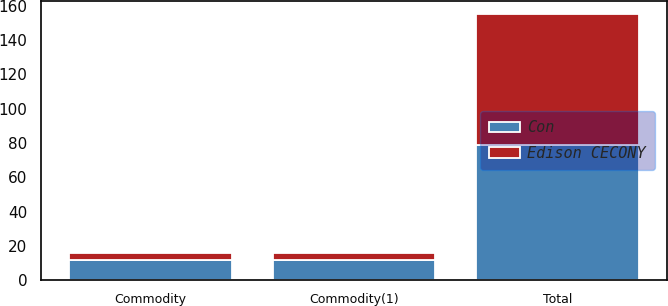<chart> <loc_0><loc_0><loc_500><loc_500><stacked_bar_chart><ecel><fcel>Total<fcel>Commodity<fcel>Commodity(1)<nl><fcel>Con<fcel>79<fcel>12<fcel>12<nl><fcel>Edison CECONY<fcel>76<fcel>4<fcel>4<nl></chart> 